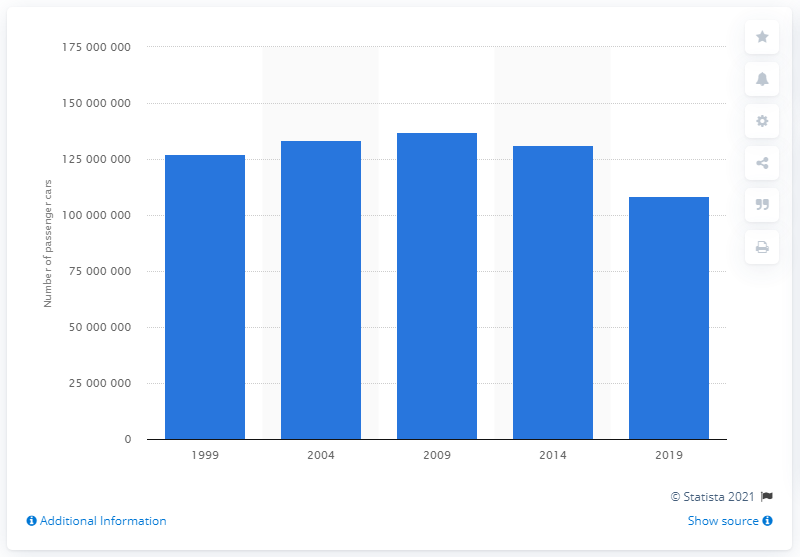Give some essential details in this illustration. In 2019, there were a total of 108,547,710 automobiles registered in the United States. 